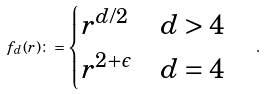Convert formula to latex. <formula><loc_0><loc_0><loc_500><loc_500>f _ { d } ( r ) \colon = \begin{cases} r ^ { d / 2 } & d > 4 \\ r ^ { 2 + \epsilon } & d = 4 \end{cases} \quad .</formula> 